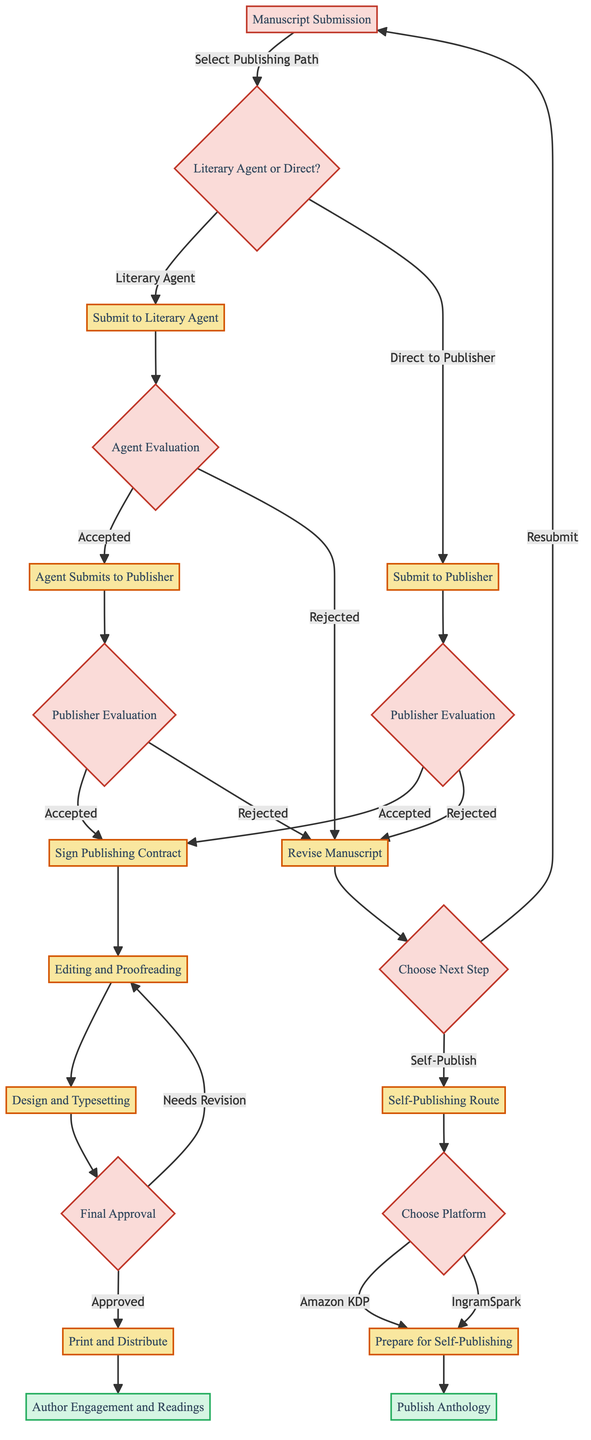What is the first step in the publication pathway? The first node in the diagram indicates that the starting point is "Manuscript Submission".
Answer: Manuscript Submission How many main options are there after manuscript submission? At the node "Manuscript Submission", there are two main options presented: "Literary Agent" and "Direct to Publisher".
Answer: 2 What happens if a manuscript is rejected by an agent? If a manuscript is rejected by an agent, the decision taken is to "Revise Manuscript" according to the node that describes "Agent Evaluation".
Answer: Revise Manuscript What step follows signing a publishing contract? After signing a publishing contract, the next step is "Editing and Proofreading" as shown in the flow from the "Sign Publishing Contract" node.
Answer: Editing and Proofreading Which option leads to self-publishing? The decision to seek self-publishing is taken after a manuscript is rejected either by a literary agent or a publisher, leading to "Self-Publishing Route".
Answer: Self-Publishing Route How many channels can a poet submit their manuscript to at the start? The diagram clearly presents two channels at the onset: "Literary Agent" and "Direct to Publisher", so there are two distinct avenues.
Answer: 2 What is the end result after preparing the manuscript for self-publishing? The end result after preparing the manuscript for self-publishing is "Publish Anthology" as indicated in the flow leading from "Prepare Manuscript for Self-Publishing".
Answer: Publish Anthology What must happen before "Print and Distribute"? Before reaching "Print and Distribute", the manuscript must go through "Design and Typesetting", which is listed as a prerequisite in the decision tree.
Answer: Design and Typesetting What occurs if design and typesetting needs revision? If the design and typesetting require revision, it goes back to "Editing and Proofreading", indicating an iterative process in the pathway.
Answer: Editing and Proofreading 